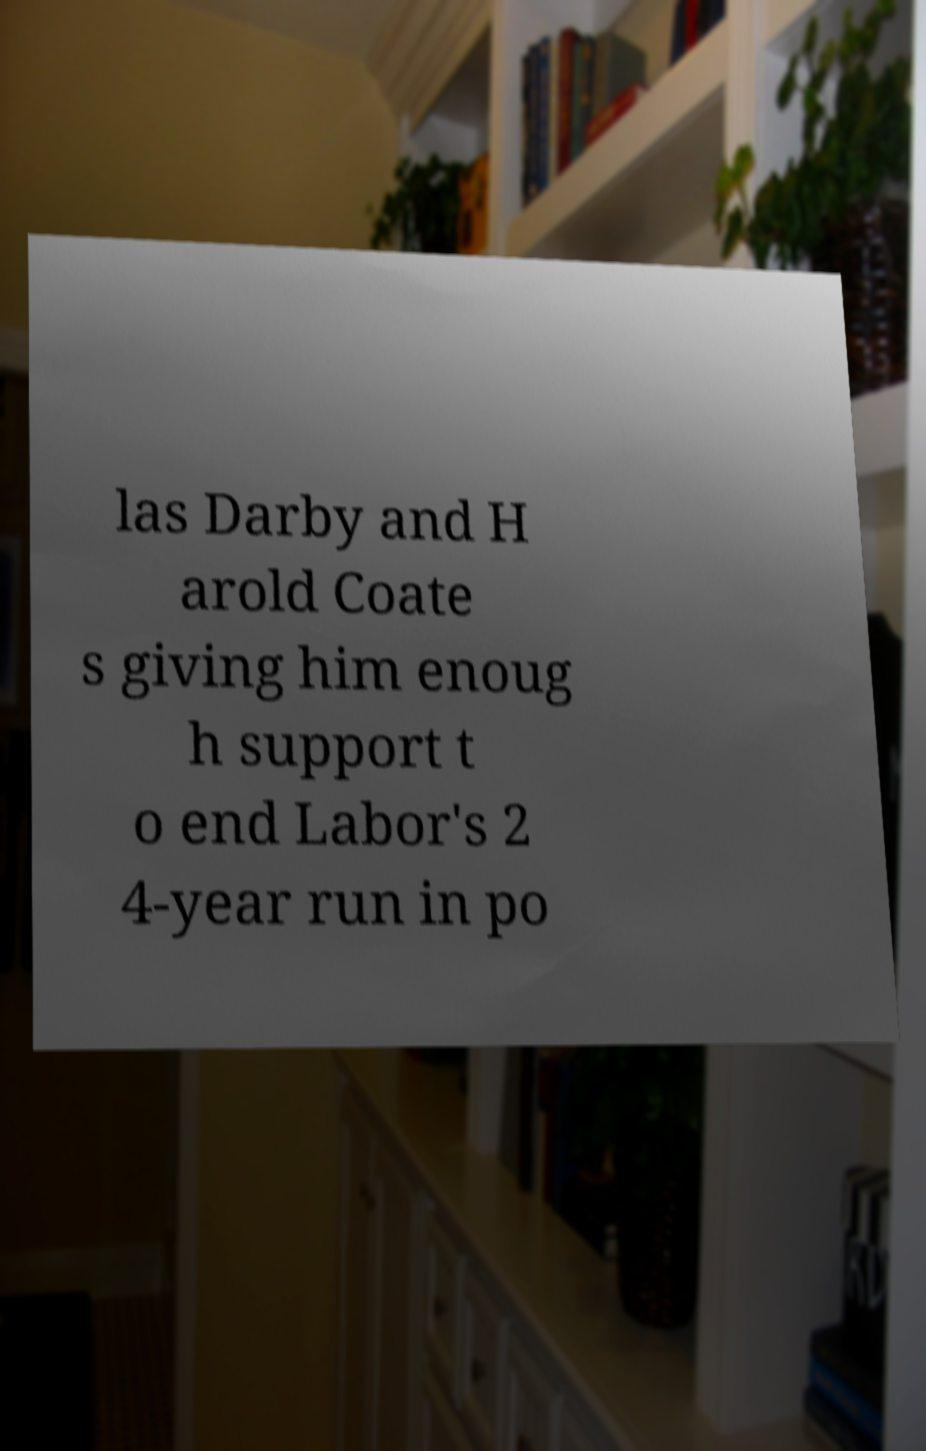What messages or text are displayed in this image? I need them in a readable, typed format. las Darby and H arold Coate s giving him enoug h support t o end Labor's 2 4-year run in po 